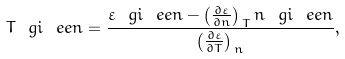<formula> <loc_0><loc_0><loc_500><loc_500>T ^ { \ } g i _ { \ } e e n = \frac { \varepsilon ^ { \ } g i _ { \ } e e n - \left ( \frac { \partial \varepsilon } { \partial n } \right ) _ { \, T } n ^ { \ } g i _ { \ } e e n } { \left ( \frac { \partial \varepsilon } { \partial T } \right ) _ { \, n } } ,</formula> 